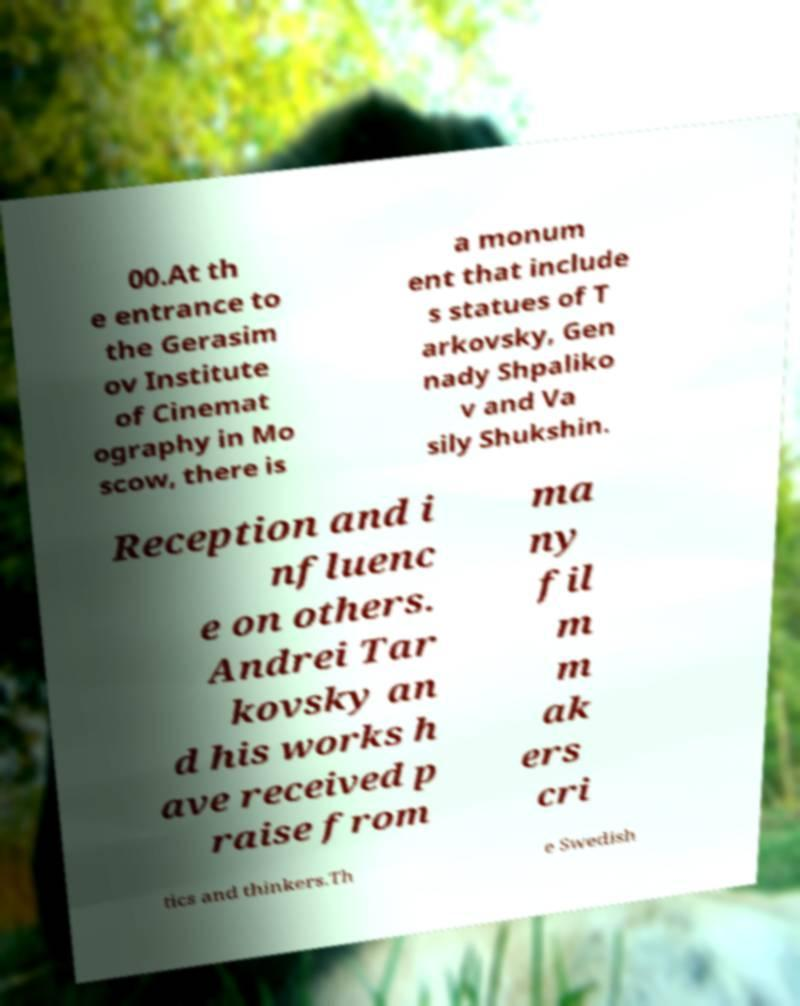Please read and relay the text visible in this image. What does it say? 00.At th e entrance to the Gerasim ov Institute of Cinemat ography in Mo scow, there is a monum ent that include s statues of T arkovsky, Gen nady Shpaliko v and Va sily Shukshin. Reception and i nfluenc e on others. Andrei Tar kovsky an d his works h ave received p raise from ma ny fil m m ak ers cri tics and thinkers.Th e Swedish 